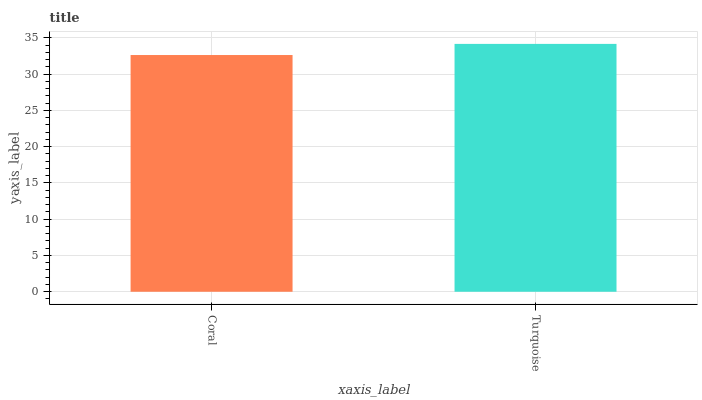Is Coral the minimum?
Answer yes or no. Yes. Is Turquoise the maximum?
Answer yes or no. Yes. Is Turquoise the minimum?
Answer yes or no. No. Is Turquoise greater than Coral?
Answer yes or no. Yes. Is Coral less than Turquoise?
Answer yes or no. Yes. Is Coral greater than Turquoise?
Answer yes or no. No. Is Turquoise less than Coral?
Answer yes or no. No. Is Turquoise the high median?
Answer yes or no. Yes. Is Coral the low median?
Answer yes or no. Yes. Is Coral the high median?
Answer yes or no. No. Is Turquoise the low median?
Answer yes or no. No. 